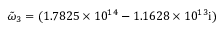<formula> <loc_0><loc_0><loc_500><loc_500>\tilde { \omega } _ { 3 } = ( 1 . 7 8 2 5 \times 1 0 ^ { 1 4 } - 1 . 1 6 2 8 \times 1 0 ^ { 1 3 } { i } )</formula> 